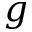Convert formula to latex. <formula><loc_0><loc_0><loc_500><loc_500>g</formula> 